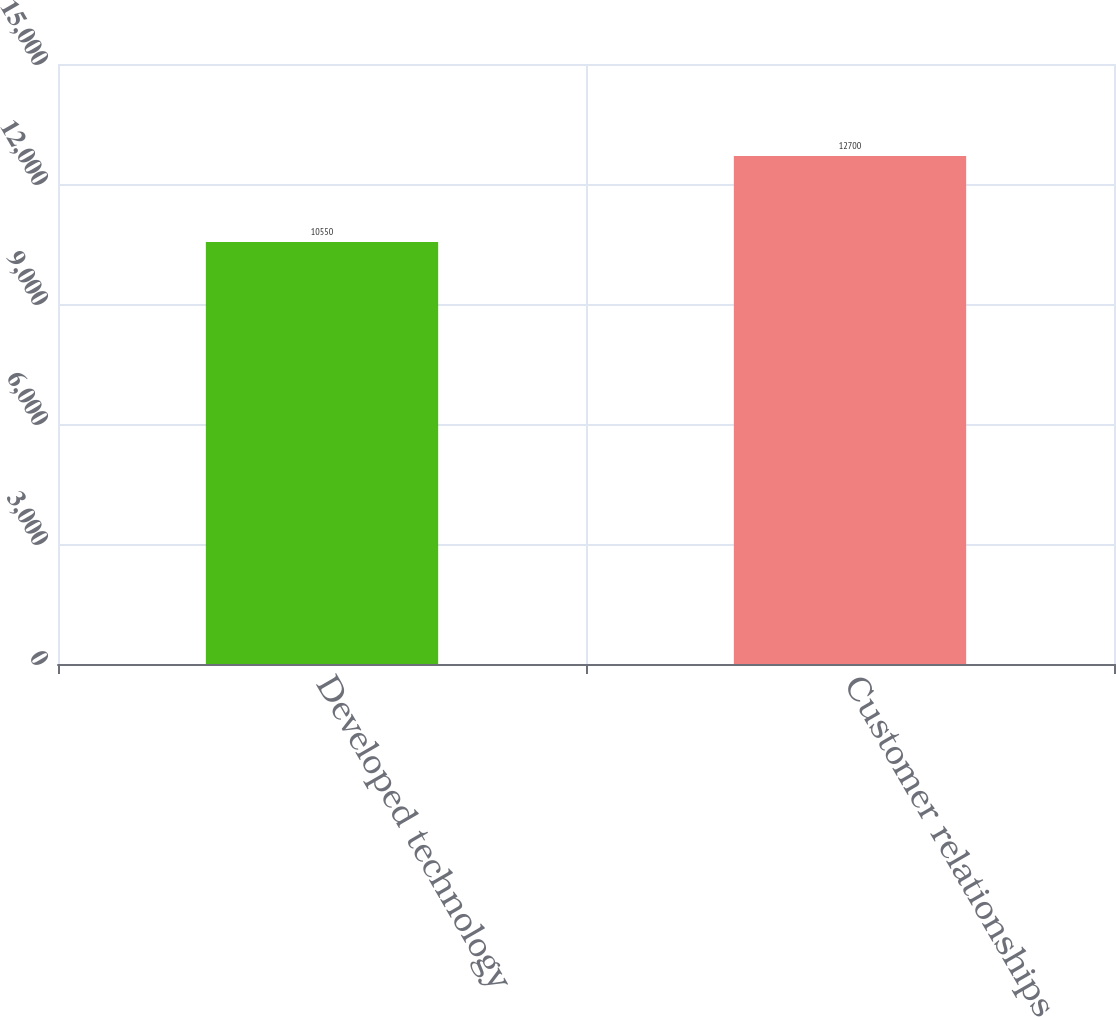Convert chart. <chart><loc_0><loc_0><loc_500><loc_500><bar_chart><fcel>Developed technology<fcel>Customer relationships<nl><fcel>10550<fcel>12700<nl></chart> 